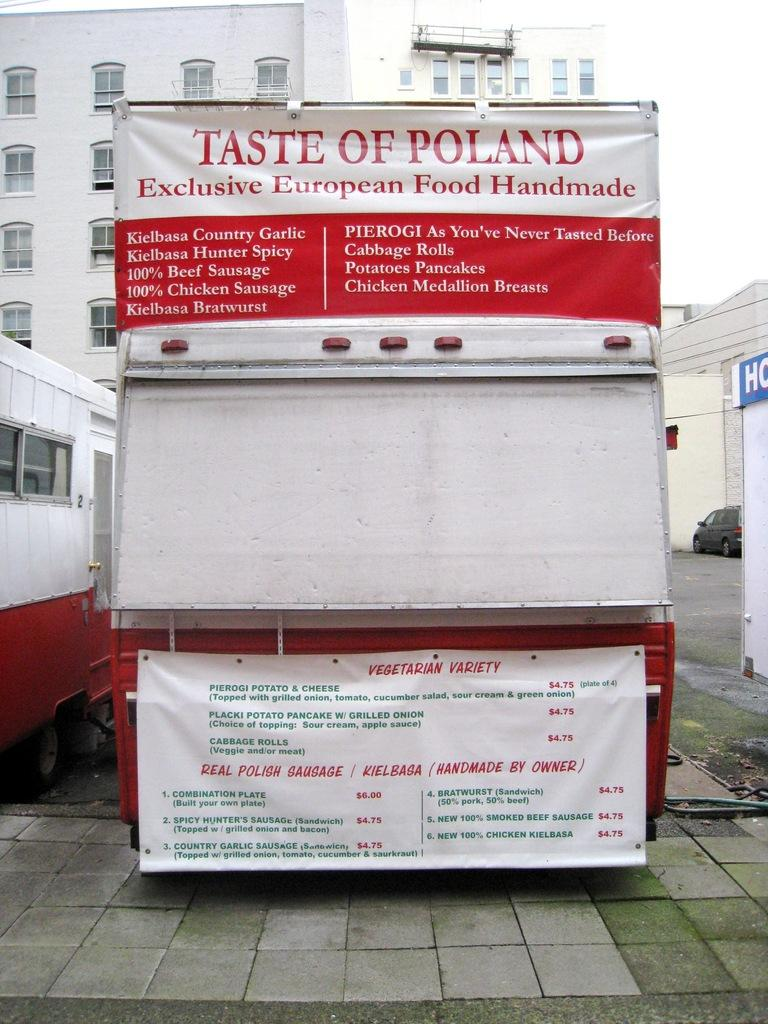What type of objects are on the ground in the image? There are vehicles on the ground in the image. What else can be seen in the image besides the vehicles? There are banners visible in the image. What can be seen in the distance in the image? There are buildings in the background of the image. What type of magic is being performed in the image? There is no magic or any indication of a performance in the image; it features vehicles, banners, and buildings. What type of brush is being used to paint the buildings in the image? There is no painting or brush visible in the image; it shows the buildings as they are. 